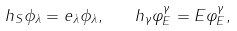Convert formula to latex. <formula><loc_0><loc_0><loc_500><loc_500>h _ { S } \phi _ { \lambda } = e _ { \lambda } \phi _ { \lambda } , \quad h _ { \gamma } \varphi _ { E } ^ { \gamma } = E \varphi _ { E } ^ { \gamma } ,</formula> 